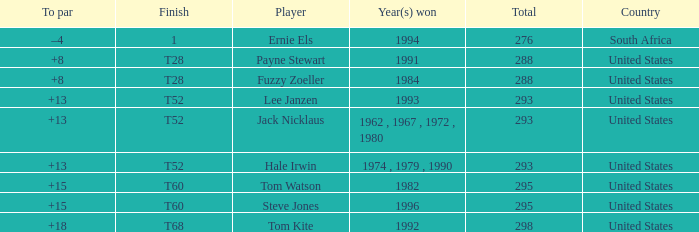Who is the player who won in 1994? Ernie Els. 